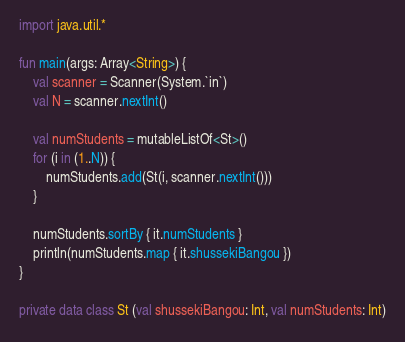<code> <loc_0><loc_0><loc_500><loc_500><_Kotlin_>import java.util.*

fun main(args: Array<String>) {
    val scanner = Scanner(System.`in`)
    val N = scanner.nextInt()

    val numStudents = mutableListOf<St>()
    for (i in (1..N)) {
        numStudents.add(St(i, scanner.nextInt()))
    }

    numStudents.sortBy { it.numStudents }
    println(numStudents.map { it.shussekiBangou })
}

private data class St (val shussekiBangou: Int, val numStudents: Int)</code> 